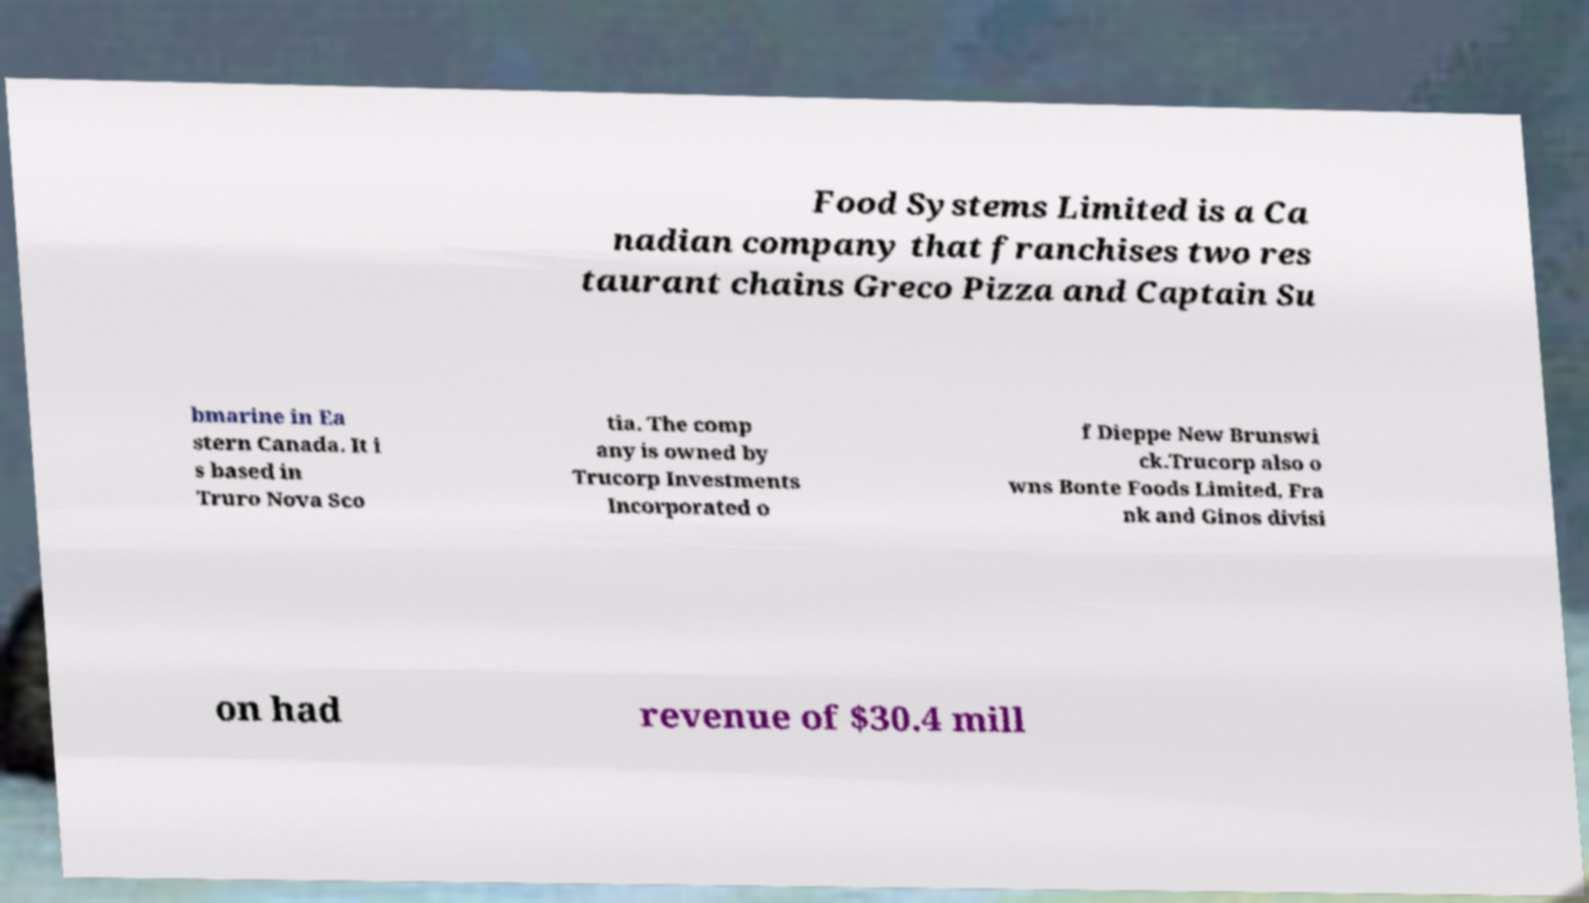For documentation purposes, I need the text within this image transcribed. Could you provide that? Food Systems Limited is a Ca nadian company that franchises two res taurant chains Greco Pizza and Captain Su bmarine in Ea stern Canada. It i s based in Truro Nova Sco tia. The comp any is owned by Trucorp Investments Incorporated o f Dieppe New Brunswi ck.Trucorp also o wns Bonte Foods Limited, Fra nk and Ginos divisi on had revenue of $30.4 mill 